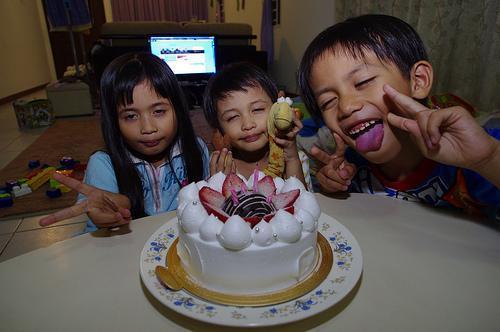How many of the children are girls?
Give a very brief answer. 1. How many children are at the table?
Give a very brief answer. 3. 